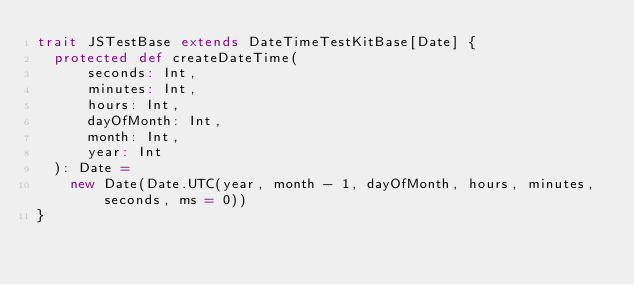Convert code to text. <code><loc_0><loc_0><loc_500><loc_500><_Scala_>trait JSTestBase extends DateTimeTestKitBase[Date] {
  protected def createDateTime(
      seconds: Int,
      minutes: Int,
      hours: Int,
      dayOfMonth: Int,
      month: Int,
      year: Int
  ): Date =
    new Date(Date.UTC(year, month - 1, dayOfMonth, hours, minutes, seconds, ms = 0))
}
</code> 